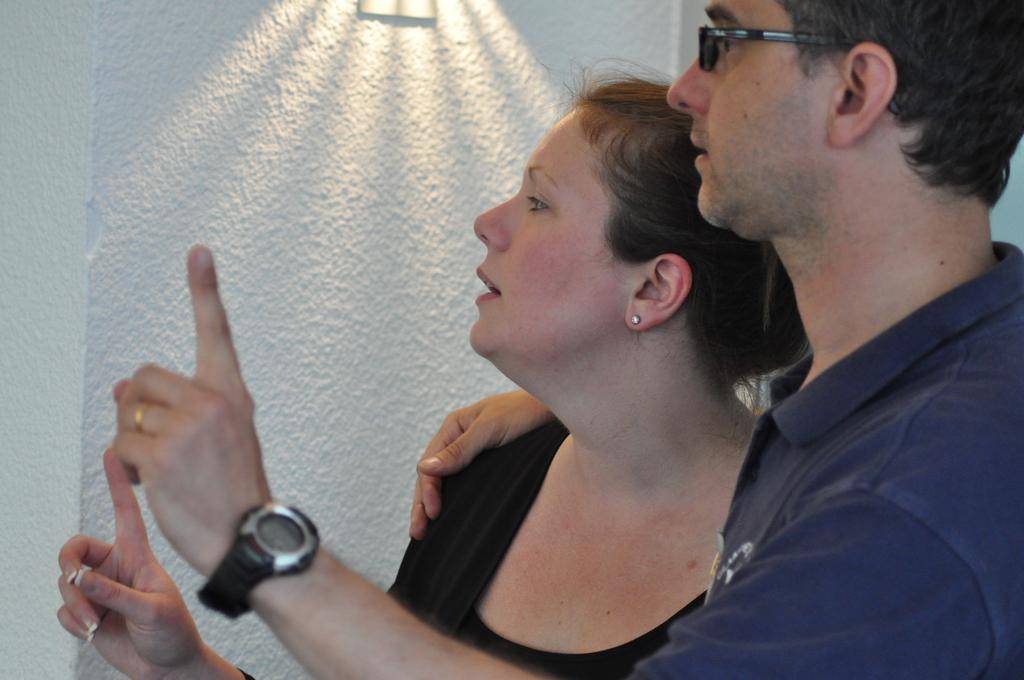What is the gender of the person in the image? There is a man in the image. What is the man wearing in the image? The man is wearing a t-shirt. What is the man doing with the woman in the image? The man is holding the shoulder of a woman. Can you describe the woman in the image? There is a woman in the image. What can be seen in the background of the image? There is a white wall in the background of the image. What type of cough medicine is the man taking in the image? There is no indication in the image that the man is taking any cough medicine. What motion is the woman performing in the image? The provided facts do not mention any specific motion performed by the woman in the image. 